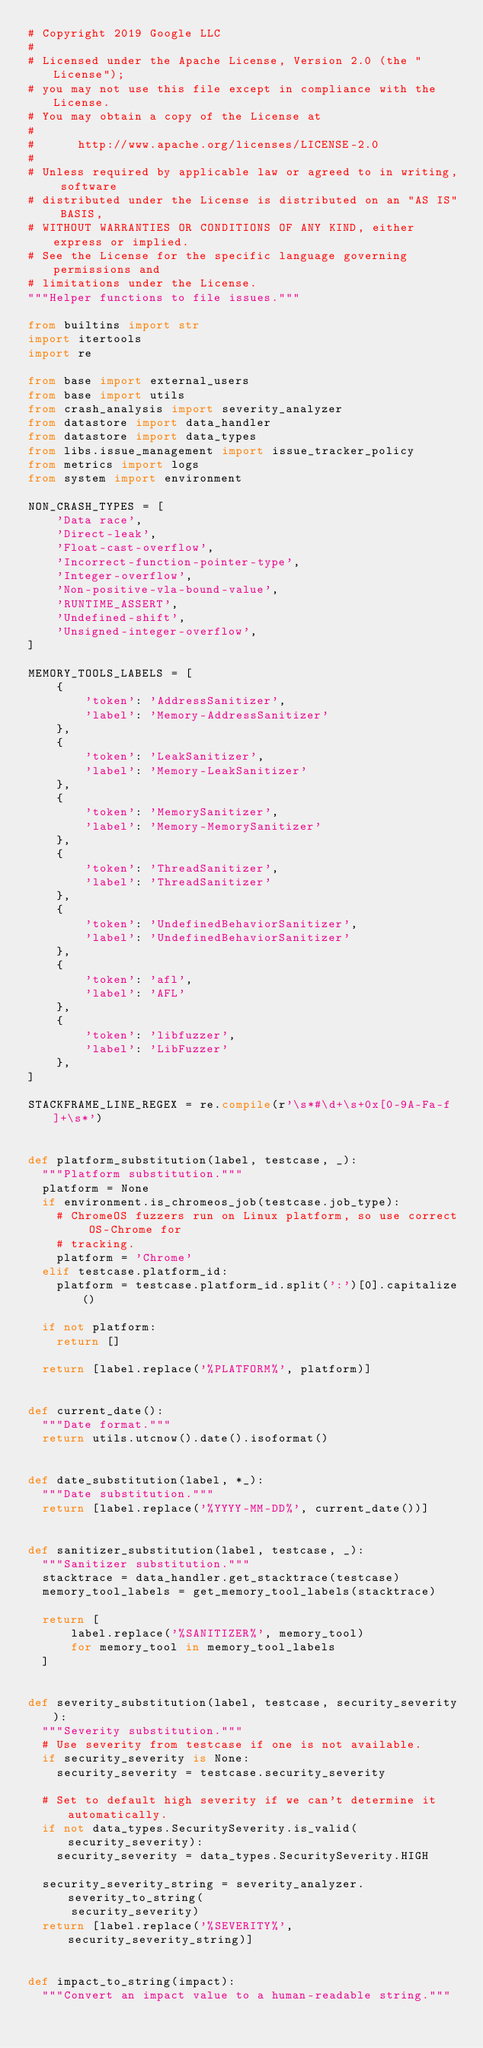Convert code to text. <code><loc_0><loc_0><loc_500><loc_500><_Python_># Copyright 2019 Google LLC
#
# Licensed under the Apache License, Version 2.0 (the "License");
# you may not use this file except in compliance with the License.
# You may obtain a copy of the License at
#
#      http://www.apache.org/licenses/LICENSE-2.0
#
# Unless required by applicable law or agreed to in writing, software
# distributed under the License is distributed on an "AS IS" BASIS,
# WITHOUT WARRANTIES OR CONDITIONS OF ANY KIND, either express or implied.
# See the License for the specific language governing permissions and
# limitations under the License.
"""Helper functions to file issues."""

from builtins import str
import itertools
import re

from base import external_users
from base import utils
from crash_analysis import severity_analyzer
from datastore import data_handler
from datastore import data_types
from libs.issue_management import issue_tracker_policy
from metrics import logs
from system import environment

NON_CRASH_TYPES = [
    'Data race',
    'Direct-leak',
    'Float-cast-overflow',
    'Incorrect-function-pointer-type',
    'Integer-overflow',
    'Non-positive-vla-bound-value',
    'RUNTIME_ASSERT',
    'Undefined-shift',
    'Unsigned-integer-overflow',
]

MEMORY_TOOLS_LABELS = [
    {
        'token': 'AddressSanitizer',
        'label': 'Memory-AddressSanitizer'
    },
    {
        'token': 'LeakSanitizer',
        'label': 'Memory-LeakSanitizer'
    },
    {
        'token': 'MemorySanitizer',
        'label': 'Memory-MemorySanitizer'
    },
    {
        'token': 'ThreadSanitizer',
        'label': 'ThreadSanitizer'
    },
    {
        'token': 'UndefinedBehaviorSanitizer',
        'label': 'UndefinedBehaviorSanitizer'
    },
    {
        'token': 'afl',
        'label': 'AFL'
    },
    {
        'token': 'libfuzzer',
        'label': 'LibFuzzer'
    },
]

STACKFRAME_LINE_REGEX = re.compile(r'\s*#\d+\s+0x[0-9A-Fa-f]+\s*')


def platform_substitution(label, testcase, _):
  """Platform substitution."""
  platform = None
  if environment.is_chromeos_job(testcase.job_type):
    # ChromeOS fuzzers run on Linux platform, so use correct OS-Chrome for
    # tracking.
    platform = 'Chrome'
  elif testcase.platform_id:
    platform = testcase.platform_id.split(':')[0].capitalize()

  if not platform:
    return []

  return [label.replace('%PLATFORM%', platform)]


def current_date():
  """Date format."""
  return utils.utcnow().date().isoformat()


def date_substitution(label, *_):
  """Date substitution."""
  return [label.replace('%YYYY-MM-DD%', current_date())]


def sanitizer_substitution(label, testcase, _):
  """Sanitizer substitution."""
  stacktrace = data_handler.get_stacktrace(testcase)
  memory_tool_labels = get_memory_tool_labels(stacktrace)

  return [
      label.replace('%SANITIZER%', memory_tool)
      for memory_tool in memory_tool_labels
  ]


def severity_substitution(label, testcase, security_severity):
  """Severity substitution."""
  # Use severity from testcase if one is not available.
  if security_severity is None:
    security_severity = testcase.security_severity

  # Set to default high severity if we can't determine it automatically.
  if not data_types.SecuritySeverity.is_valid(security_severity):
    security_severity = data_types.SecuritySeverity.HIGH

  security_severity_string = severity_analyzer.severity_to_string(
      security_severity)
  return [label.replace('%SEVERITY%', security_severity_string)]


def impact_to_string(impact):
  """Convert an impact value to a human-readable string."""</code> 